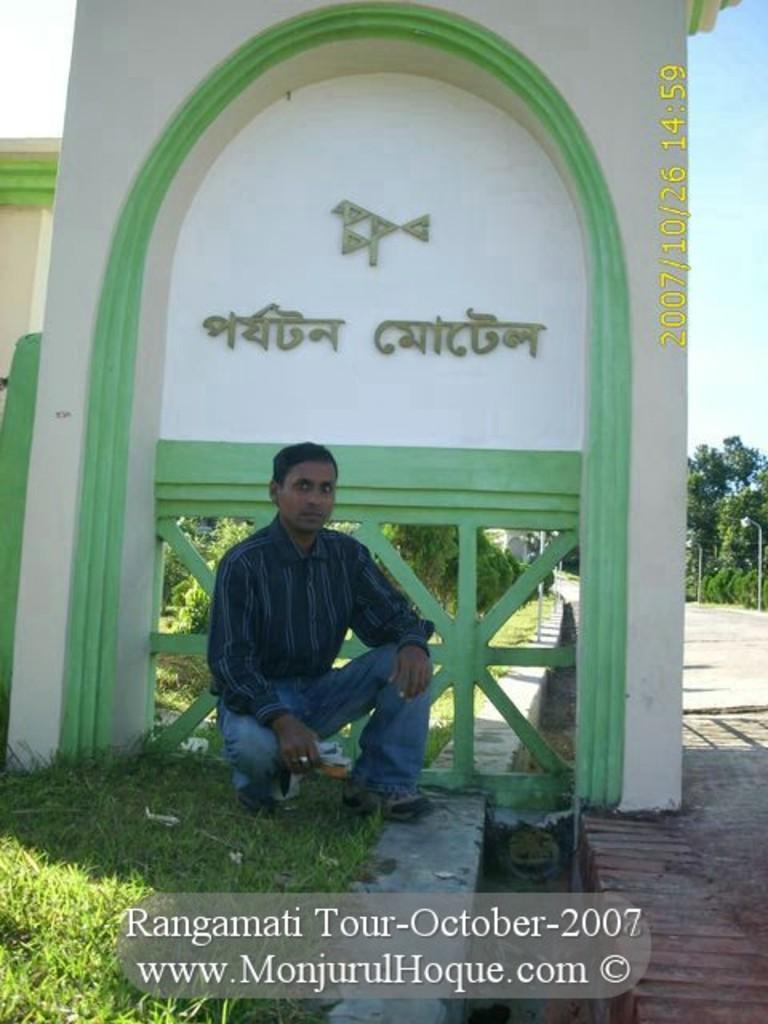How would you summarize this image in a sentence or two? In this image we can see a person, behind him we can see the wall with some text, there are some trees, plants, poles, lights and grass, also we can see the sky, at the bottom of the image we can see the text. 